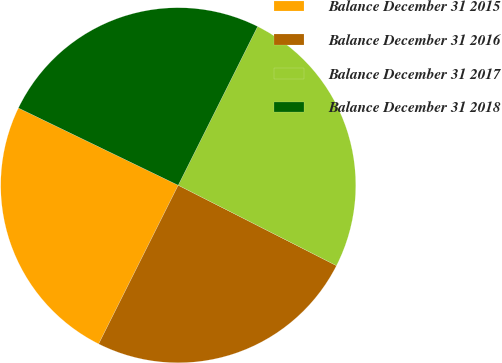Convert chart to OTSL. <chart><loc_0><loc_0><loc_500><loc_500><pie_chart><fcel>Balance December 31 2015<fcel>Balance December 31 2016<fcel>Balance December 31 2017<fcel>Balance December 31 2018<nl><fcel>24.77%<fcel>24.91%<fcel>25.1%<fcel>25.21%<nl></chart> 